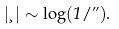<formula> <loc_0><loc_0><loc_500><loc_500>| \xi | \sim \log ( 1 / \varepsilon ) .</formula> 